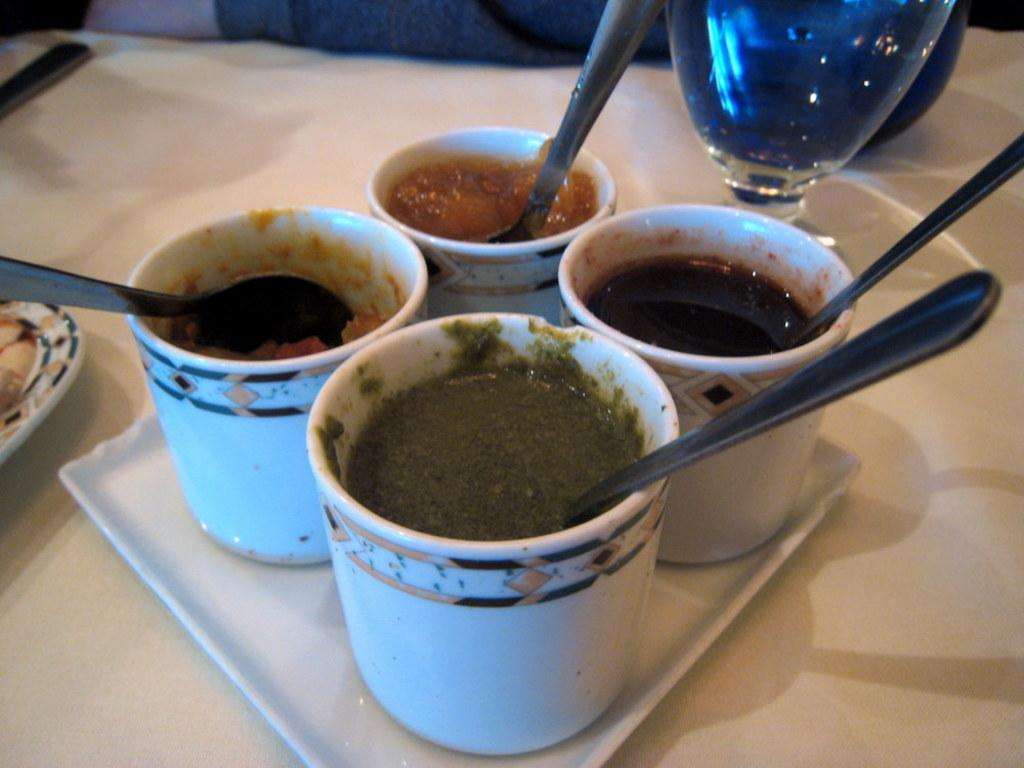What is on the platform in the image? There is a tray on a platform in the image. What is on the tray? The tray contains cups with food. How are the cups prepared for eating? The cups have spoons in them. What can be seen in the background of the image? There is a glass and a spoon in the background of the image, along with other objects. How many cherries are on the spoon in the image? There are no cherries present in the image. What color is the ink on the spoon in the image? There is no ink present in the image. 